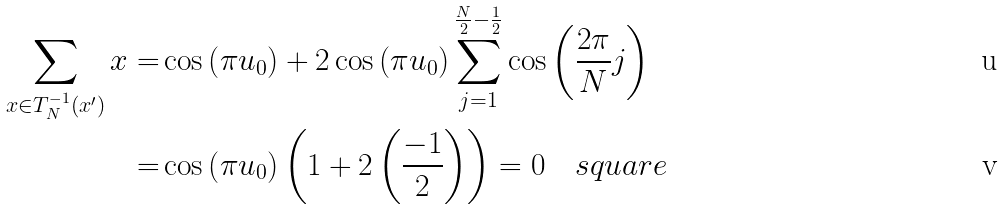Convert formula to latex. <formula><loc_0><loc_0><loc_500><loc_500>\sum _ { x \in T _ { N } ^ { - 1 } ( x ^ { \prime } ) } x = & \cos \left ( \pi u _ { 0 } \right ) + 2 \cos \left ( \pi u _ { 0 } \right ) \sum _ { j = 1 } ^ { \frac { N } { 2 } - \frac { 1 } { 2 } } \cos \left ( \frac { 2 \pi } { N } j \right ) \\ = & \cos \left ( \pi u _ { 0 } \right ) \left ( 1 + 2 \left ( \frac { - 1 } { 2 } \right ) \right ) = 0 \quad s q u a r e</formula> 